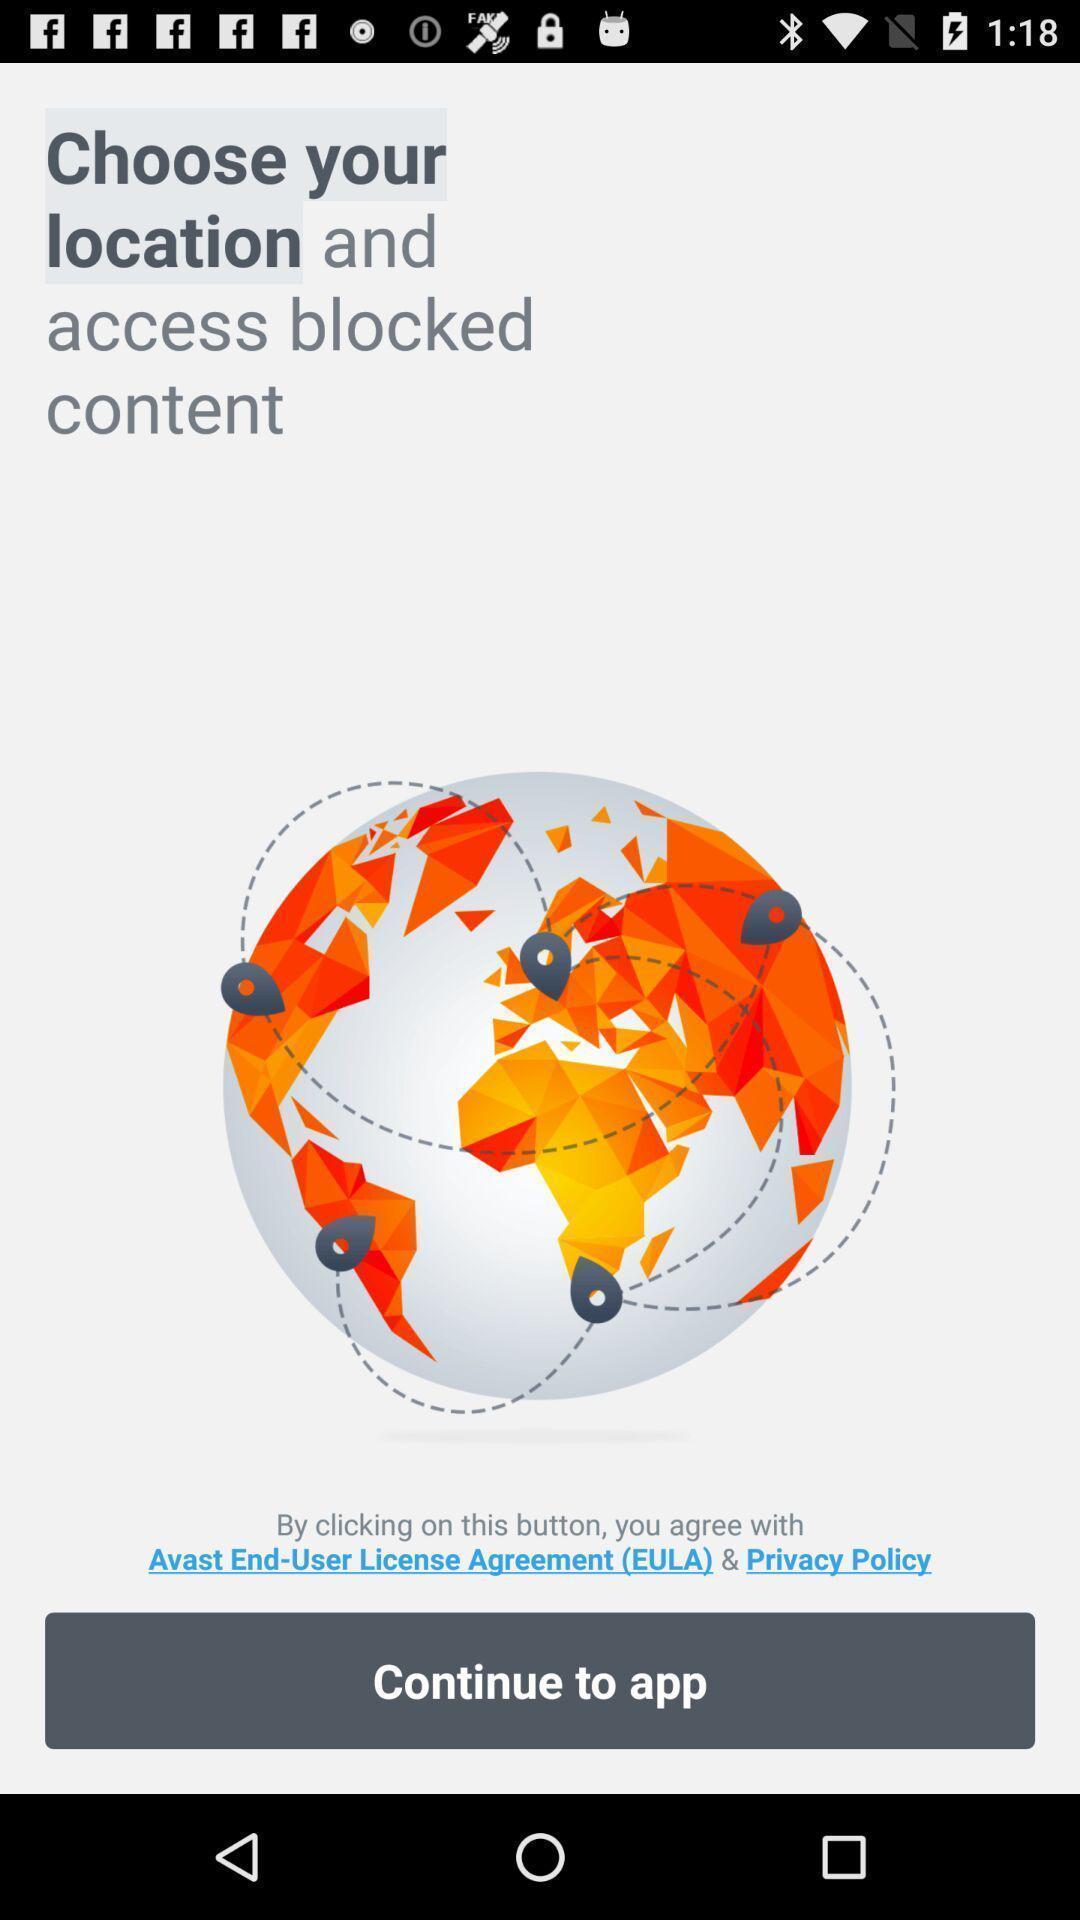Describe this image in words. Screen displaying information. 